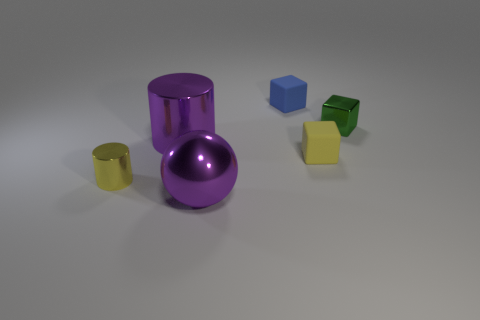There is a small blue object; does it have the same shape as the small rubber thing in front of the green metallic thing?
Offer a very short reply. Yes. What is the tiny yellow cube made of?
Your answer should be very brief. Rubber. There is a tiny matte block behind the small green shiny object right of the big purple thing to the left of the large purple sphere; what is its color?
Give a very brief answer. Blue. There is a small blue thing that is the same shape as the yellow rubber object; what is its material?
Keep it short and to the point. Rubber. How many cyan cylinders are the same size as the green shiny cube?
Make the answer very short. 0. What number of objects are there?
Your answer should be very brief. 6. Is the yellow block made of the same material as the tiny cylinder left of the tiny green cube?
Offer a very short reply. No. What number of green objects are small objects or small matte blocks?
Offer a very short reply. 1. There is a purple ball that is made of the same material as the small green block; what is its size?
Give a very brief answer. Large. What number of other tiny green objects are the same shape as the tiny green object?
Provide a short and direct response. 0. 